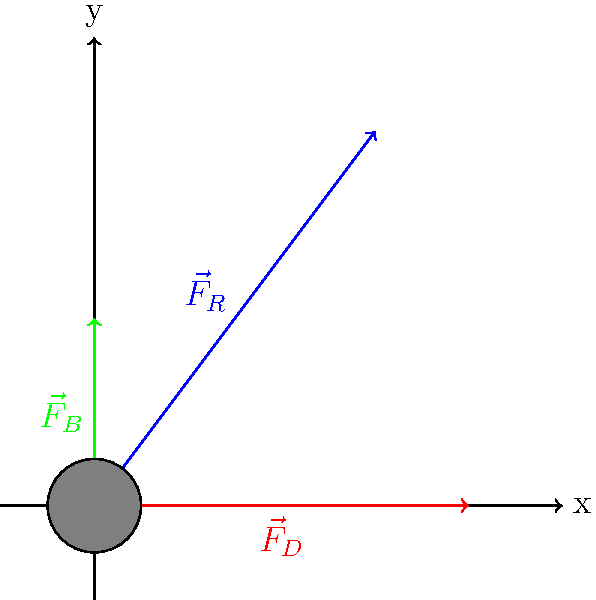During the excavation of a submerged medieval artifact, three primary forces act upon it: the resultant force $\vec{F}_R$ (blue), the drag force $\vec{F}_D$ (red), and the buoyancy force $\vec{F}_B$ (green). Given that $\vec{F}_R = 3\hat{i} + 4\hat{j}$, $\vec{F}_D = 4\hat{i}$, and $|\vec{F}_B| = 2$, calculate the magnitude of the net force acting on the artifact. To find the magnitude of the net force, we need to follow these steps:

1) First, we need to determine the components of all forces:
   $\vec{F}_R = 3\hat{i} + 4\hat{j}$
   $\vec{F}_D = 4\hat{i} + 0\hat{j}$
   $\vec{F}_B = 0\hat{i} + 2\hat{j}$ (given that $|\vec{F}_B| = 2$ and it's in the positive y direction)

2) Now, we sum up all the force vectors to get the net force:
   $\vec{F}_{net} = \vec{F}_R + \vec{F}_D + \vec{F}_B$

3) Let's add the components:
   $\vec{F}_{net} = (3+4+0)\hat{i} + (4+0+2)\hat{j}$
   $\vec{F}_{net} = 7\hat{i} + 6\hat{j}$

4) To find the magnitude of this net force, we use the Pythagorean theorem:
   $|\vec{F}_{net}| = \sqrt{(7)^2 + (6)^2}$

5) Calculate:
   $|\vec{F}_{net}| = \sqrt{49 + 36} = \sqrt{85}$

Therefore, the magnitude of the net force is $\sqrt{85}$ units.
Answer: $\sqrt{85}$ units 